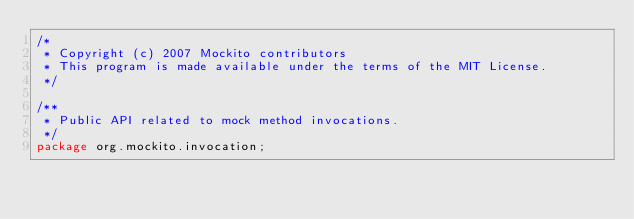Convert code to text. <code><loc_0><loc_0><loc_500><loc_500><_Java_>/*
 * Copyright (c) 2007 Mockito contributors
 * This program is made available under the terms of the MIT License.
 */

/**
 * Public API related to mock method invocations.
 */
package org.mockito.invocation;
</code> 